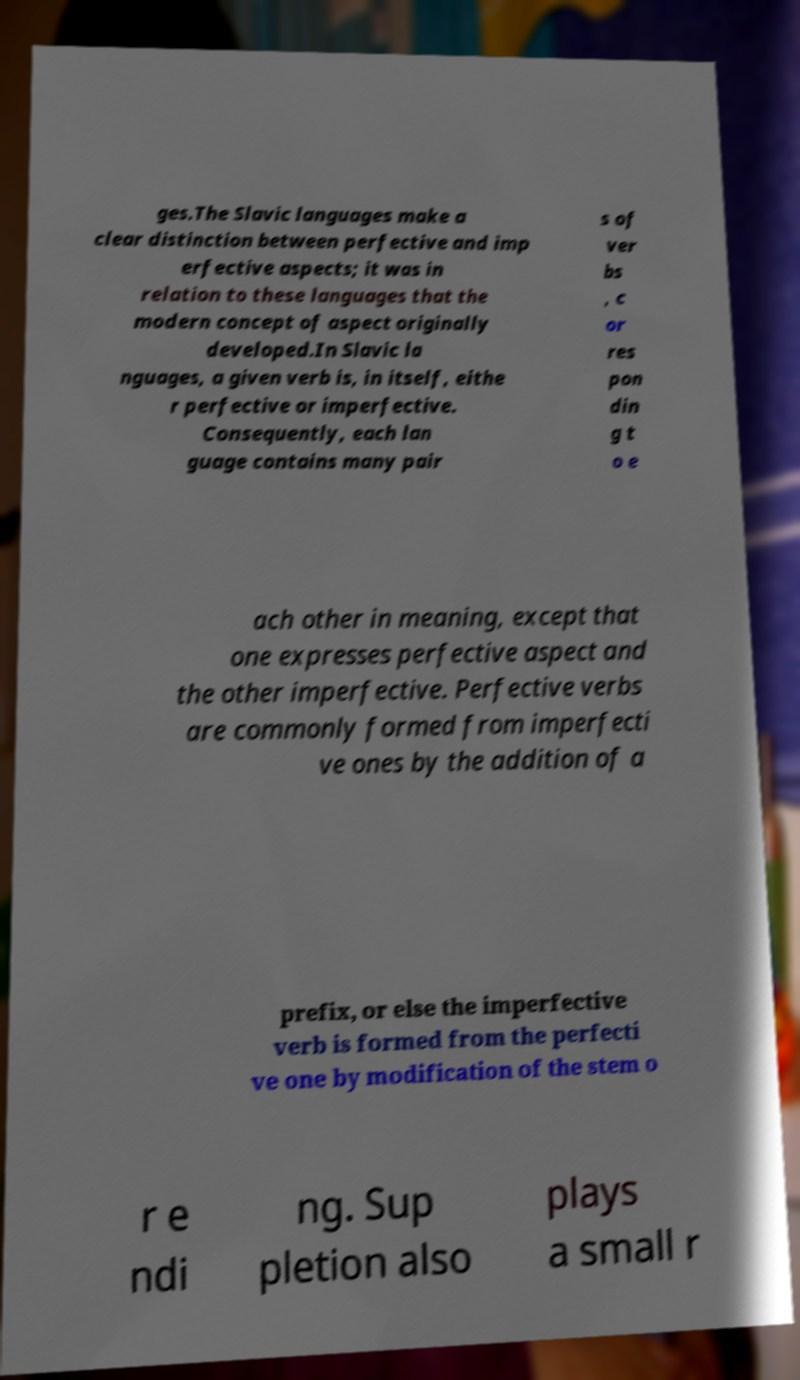I need the written content from this picture converted into text. Can you do that? ges.The Slavic languages make a clear distinction between perfective and imp erfective aspects; it was in relation to these languages that the modern concept of aspect originally developed.In Slavic la nguages, a given verb is, in itself, eithe r perfective or imperfective. Consequently, each lan guage contains many pair s of ver bs , c or res pon din g t o e ach other in meaning, except that one expresses perfective aspect and the other imperfective. Perfective verbs are commonly formed from imperfecti ve ones by the addition of a prefix, or else the imperfective verb is formed from the perfecti ve one by modification of the stem o r e ndi ng. Sup pletion also plays a small r 